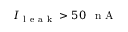Convert formula to latex. <formula><loc_0><loc_0><loc_500><loc_500>I _ { l e a k } > 5 0 \, n A</formula> 